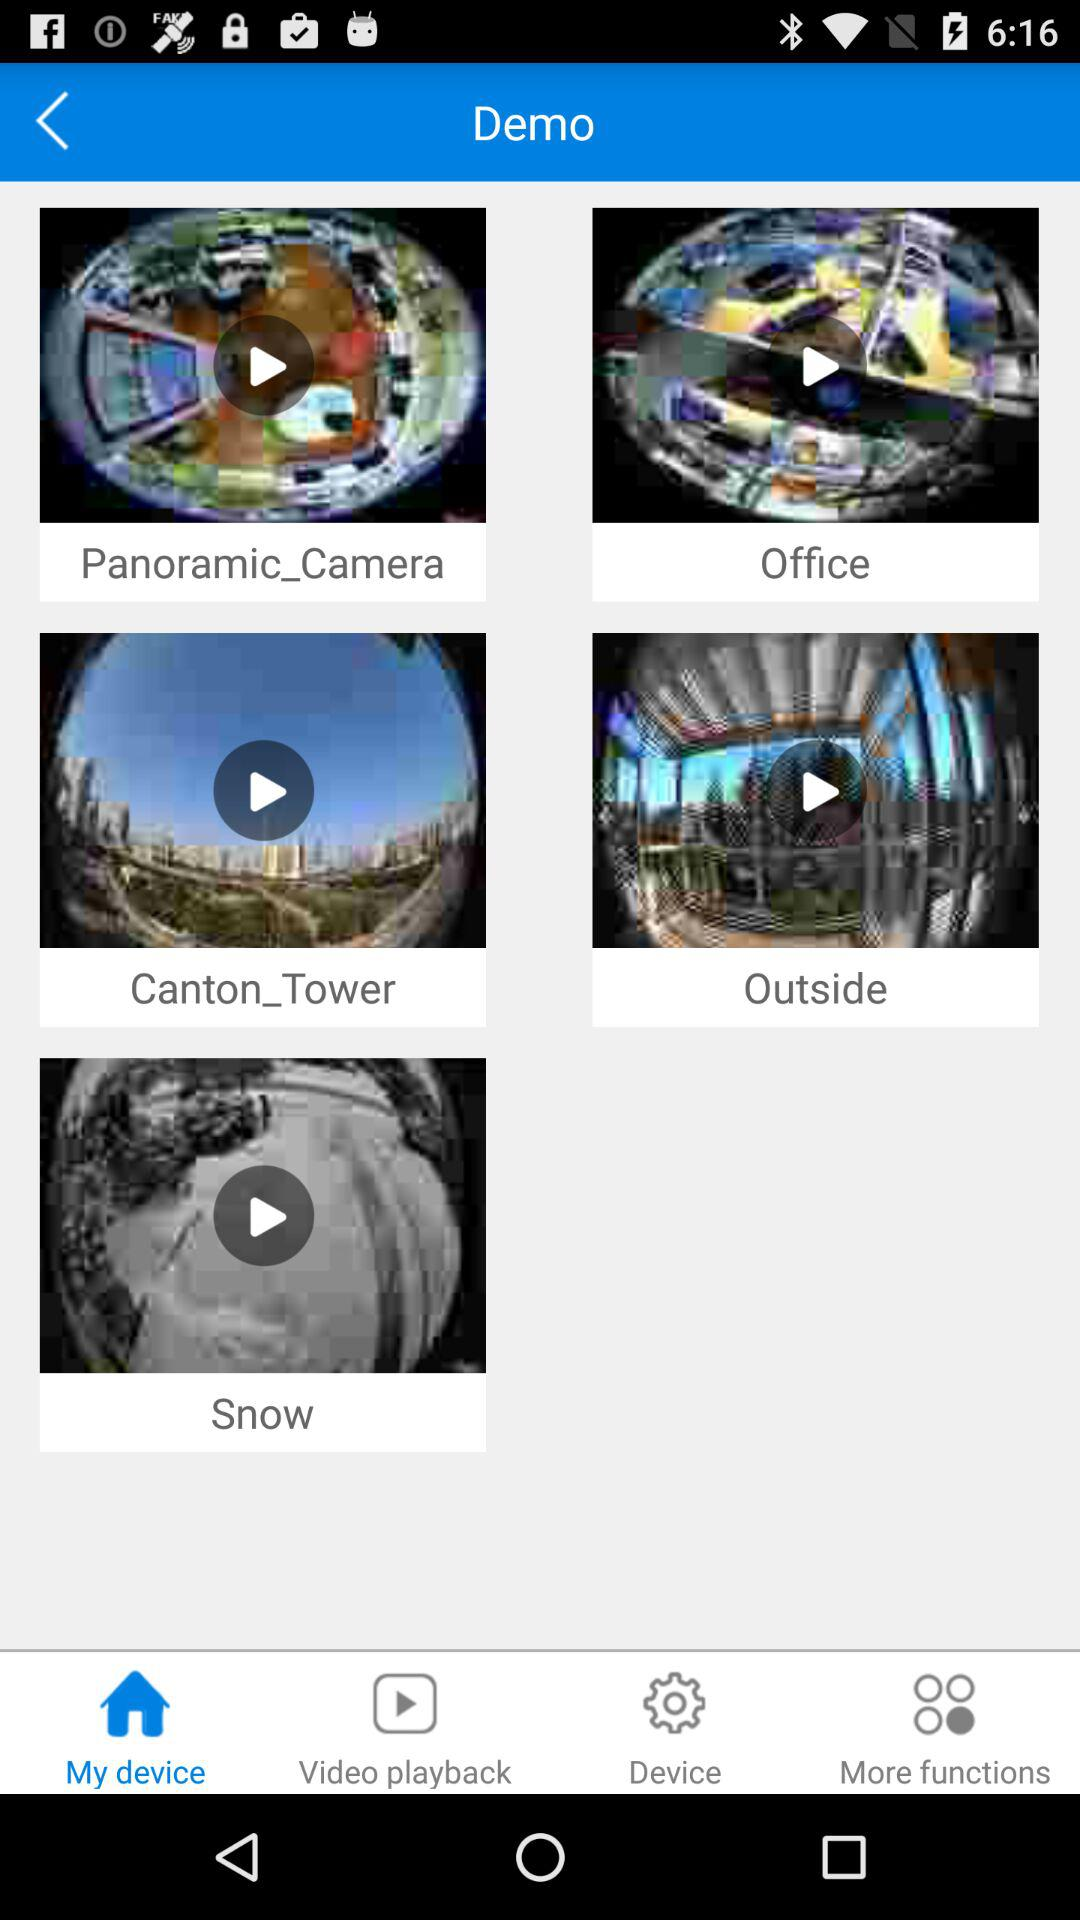Which tab is selected? The selected tab is "My device". 